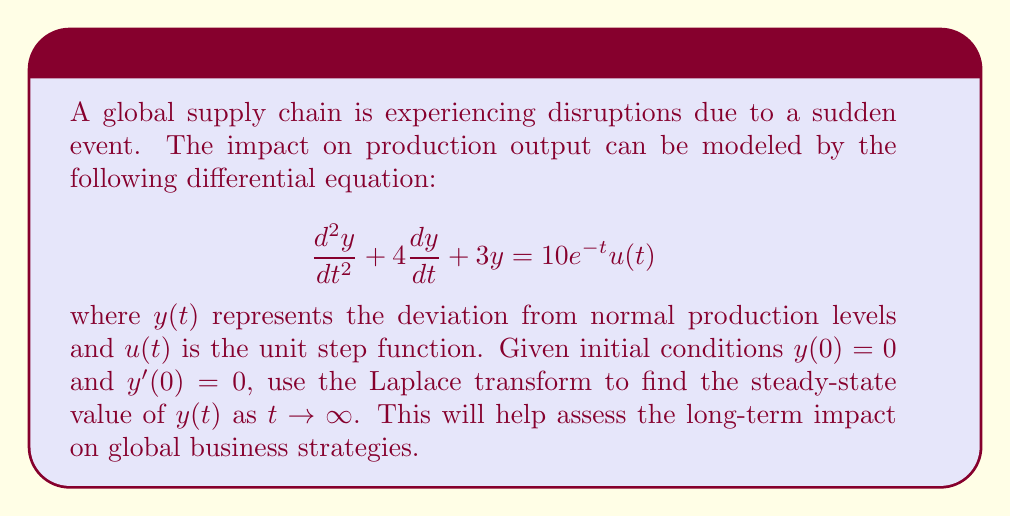Teach me how to tackle this problem. To solve this problem, we'll use the following steps:

1) Take the Laplace transform of both sides of the differential equation:
   $$\mathcal{L}\{y''(t) + 4y'(t) + 3y(t)\} = \mathcal{L}\{10e^{-t}u(t)\}$$

2) Using Laplace transform properties:
   $$(s^2Y(s) - sy(0) - y'(0)) + 4(sY(s) - y(0)) + 3Y(s) = \frac{10}{s+1}$$

3) Substitute initial conditions $y(0) = 0$ and $y'(0) = 0$:
   $$s^2Y(s) + 4sY(s) + 3Y(s) = \frac{10}{s+1}$$

4) Factor out $Y(s)$:
   $$Y(s)(s^2 + 4s + 3) = \frac{10}{s+1}$$

5) Solve for $Y(s)$:
   $$Y(s) = \frac{10}{(s+1)(s^2 + 4s + 3)}$$

6) Use partial fraction decomposition:
   $$Y(s) = \frac{A}{s+1} + \frac{Bs+C}{s^2 + 4s + 3}$$

7) Find $A$, $B$, and $C$:
   $$A = \frac{10}{6} = \frac{5}{3}, B = -\frac{5}{3}, C = \frac{10}{3}$$

8) Rewrite $Y(s)$:
   $$Y(s) = \frac{5/3}{s+1} - \frac{5/3}{s+3} + \frac{5/3}{s+1}$$

9) Take the inverse Laplace transform:
   $$y(t) = \frac{5}{3}e^{-t} - \frac{5}{3}e^{-3t} + \frac{5}{3}e^{-t}$$

10) Simplify:
    $$y(t) = \frac{10}{3}e^{-t} - \frac{5}{3}e^{-3t}$$

11) To find the steady-state value, take the limit as $t \to \infty$:
    $$\lim_{t \to \infty} y(t) = \lim_{t \to \infty} (\frac{10}{3}e^{-t} - \frac{5}{3}e^{-3t}) = 0$$

Therefore, the steady-state value of $y(t)$ as $t \to \infty$ is 0.
Answer: The steady-state value of $y(t)$ as $t \to \infty$ is 0. 